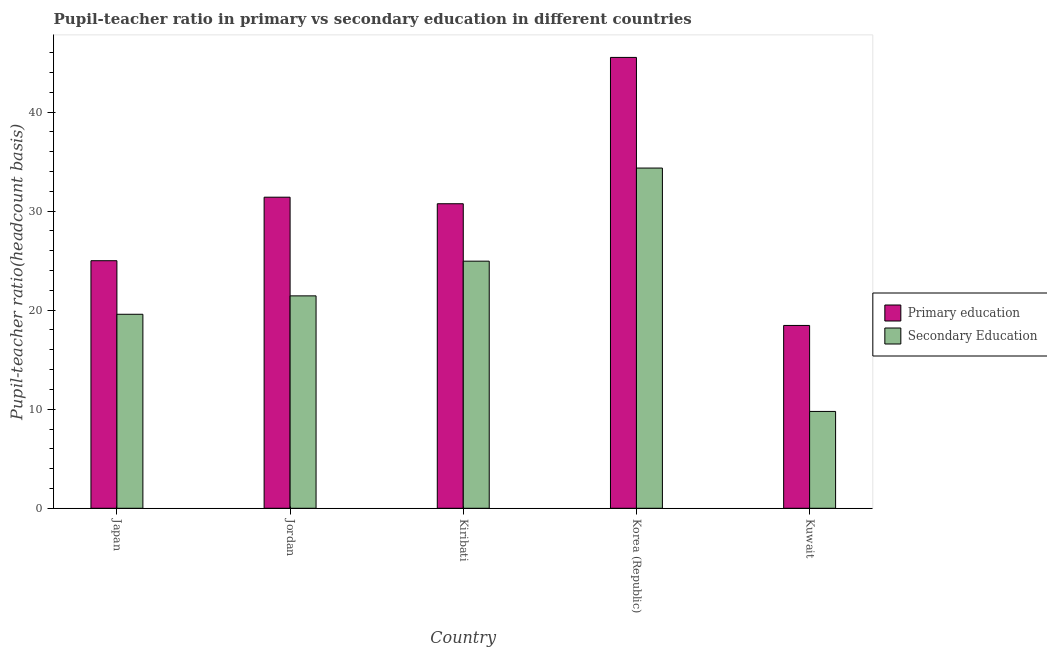How many different coloured bars are there?
Provide a succinct answer. 2. Are the number of bars per tick equal to the number of legend labels?
Your response must be concise. Yes. Are the number of bars on each tick of the X-axis equal?
Your response must be concise. Yes. How many bars are there on the 2nd tick from the right?
Offer a terse response. 2. What is the label of the 3rd group of bars from the left?
Your answer should be very brief. Kiribati. What is the pupil-teacher ratio in primary education in Korea (Republic)?
Give a very brief answer. 45.52. Across all countries, what is the maximum pupil-teacher ratio in primary education?
Offer a very short reply. 45.52. Across all countries, what is the minimum pupil-teacher ratio in primary education?
Your answer should be very brief. 18.46. In which country was the pupil teacher ratio on secondary education minimum?
Your answer should be very brief. Kuwait. What is the total pupil teacher ratio on secondary education in the graph?
Provide a short and direct response. 110.11. What is the difference between the pupil-teacher ratio in primary education in Japan and that in Kiribati?
Make the answer very short. -5.75. What is the difference between the pupil-teacher ratio in primary education in Korea (Republic) and the pupil teacher ratio on secondary education in Kuwait?
Offer a terse response. 35.74. What is the average pupil teacher ratio on secondary education per country?
Your answer should be very brief. 22.02. What is the difference between the pupil-teacher ratio in primary education and pupil teacher ratio on secondary education in Kuwait?
Offer a terse response. 8.68. In how many countries, is the pupil-teacher ratio in primary education greater than 28 ?
Your answer should be compact. 3. What is the ratio of the pupil-teacher ratio in primary education in Jordan to that in Kiribati?
Provide a short and direct response. 1.02. What is the difference between the highest and the second highest pupil teacher ratio on secondary education?
Your response must be concise. 9.4. What is the difference between the highest and the lowest pupil teacher ratio on secondary education?
Ensure brevity in your answer.  24.57. In how many countries, is the pupil teacher ratio on secondary education greater than the average pupil teacher ratio on secondary education taken over all countries?
Keep it short and to the point. 2. What does the 2nd bar from the left in Kiribati represents?
Your answer should be very brief. Secondary Education. What does the 2nd bar from the right in Kuwait represents?
Your answer should be very brief. Primary education. How many countries are there in the graph?
Your answer should be very brief. 5. What is the difference between two consecutive major ticks on the Y-axis?
Offer a terse response. 10. Where does the legend appear in the graph?
Make the answer very short. Center right. What is the title of the graph?
Keep it short and to the point. Pupil-teacher ratio in primary vs secondary education in different countries. Does "Male labourers" appear as one of the legend labels in the graph?
Offer a very short reply. No. What is the label or title of the X-axis?
Your response must be concise. Country. What is the label or title of the Y-axis?
Offer a very short reply. Pupil-teacher ratio(headcount basis). What is the Pupil-teacher ratio(headcount basis) of Primary education in Japan?
Keep it short and to the point. 24.99. What is the Pupil-teacher ratio(headcount basis) of Secondary Education in Japan?
Your response must be concise. 19.59. What is the Pupil-teacher ratio(headcount basis) of Primary education in Jordan?
Provide a succinct answer. 31.41. What is the Pupil-teacher ratio(headcount basis) in Secondary Education in Jordan?
Your response must be concise. 21.45. What is the Pupil-teacher ratio(headcount basis) of Primary education in Kiribati?
Keep it short and to the point. 30.75. What is the Pupil-teacher ratio(headcount basis) in Secondary Education in Kiribati?
Ensure brevity in your answer.  24.95. What is the Pupil-teacher ratio(headcount basis) in Primary education in Korea (Republic)?
Offer a very short reply. 45.52. What is the Pupil-teacher ratio(headcount basis) in Secondary Education in Korea (Republic)?
Offer a terse response. 34.35. What is the Pupil-teacher ratio(headcount basis) of Primary education in Kuwait?
Your answer should be compact. 18.46. What is the Pupil-teacher ratio(headcount basis) in Secondary Education in Kuwait?
Make the answer very short. 9.78. Across all countries, what is the maximum Pupil-teacher ratio(headcount basis) of Primary education?
Offer a very short reply. 45.52. Across all countries, what is the maximum Pupil-teacher ratio(headcount basis) in Secondary Education?
Your answer should be very brief. 34.35. Across all countries, what is the minimum Pupil-teacher ratio(headcount basis) of Primary education?
Offer a very short reply. 18.46. Across all countries, what is the minimum Pupil-teacher ratio(headcount basis) in Secondary Education?
Give a very brief answer. 9.78. What is the total Pupil-teacher ratio(headcount basis) in Primary education in the graph?
Ensure brevity in your answer.  151.13. What is the total Pupil-teacher ratio(headcount basis) in Secondary Education in the graph?
Offer a very short reply. 110.11. What is the difference between the Pupil-teacher ratio(headcount basis) of Primary education in Japan and that in Jordan?
Offer a very short reply. -6.41. What is the difference between the Pupil-teacher ratio(headcount basis) in Secondary Education in Japan and that in Jordan?
Offer a very short reply. -1.86. What is the difference between the Pupil-teacher ratio(headcount basis) in Primary education in Japan and that in Kiribati?
Provide a succinct answer. -5.75. What is the difference between the Pupil-teacher ratio(headcount basis) of Secondary Education in Japan and that in Kiribati?
Provide a short and direct response. -5.36. What is the difference between the Pupil-teacher ratio(headcount basis) in Primary education in Japan and that in Korea (Republic)?
Offer a very short reply. -20.53. What is the difference between the Pupil-teacher ratio(headcount basis) of Secondary Education in Japan and that in Korea (Republic)?
Make the answer very short. -14.76. What is the difference between the Pupil-teacher ratio(headcount basis) of Primary education in Japan and that in Kuwait?
Keep it short and to the point. 6.54. What is the difference between the Pupil-teacher ratio(headcount basis) of Secondary Education in Japan and that in Kuwait?
Your response must be concise. 9.81. What is the difference between the Pupil-teacher ratio(headcount basis) of Primary education in Jordan and that in Kiribati?
Make the answer very short. 0.66. What is the difference between the Pupil-teacher ratio(headcount basis) in Secondary Education in Jordan and that in Kiribati?
Make the answer very short. -3.5. What is the difference between the Pupil-teacher ratio(headcount basis) of Primary education in Jordan and that in Korea (Republic)?
Offer a terse response. -14.11. What is the difference between the Pupil-teacher ratio(headcount basis) of Secondary Education in Jordan and that in Korea (Republic)?
Offer a terse response. -12.9. What is the difference between the Pupil-teacher ratio(headcount basis) of Primary education in Jordan and that in Kuwait?
Keep it short and to the point. 12.95. What is the difference between the Pupil-teacher ratio(headcount basis) of Secondary Education in Jordan and that in Kuwait?
Keep it short and to the point. 11.67. What is the difference between the Pupil-teacher ratio(headcount basis) of Primary education in Kiribati and that in Korea (Republic)?
Ensure brevity in your answer.  -14.77. What is the difference between the Pupil-teacher ratio(headcount basis) in Secondary Education in Kiribati and that in Korea (Republic)?
Provide a short and direct response. -9.4. What is the difference between the Pupil-teacher ratio(headcount basis) of Primary education in Kiribati and that in Kuwait?
Make the answer very short. 12.29. What is the difference between the Pupil-teacher ratio(headcount basis) in Secondary Education in Kiribati and that in Kuwait?
Your answer should be very brief. 15.17. What is the difference between the Pupil-teacher ratio(headcount basis) of Primary education in Korea (Republic) and that in Kuwait?
Keep it short and to the point. 27.06. What is the difference between the Pupil-teacher ratio(headcount basis) in Secondary Education in Korea (Republic) and that in Kuwait?
Your answer should be compact. 24.57. What is the difference between the Pupil-teacher ratio(headcount basis) in Primary education in Japan and the Pupil-teacher ratio(headcount basis) in Secondary Education in Jordan?
Offer a very short reply. 3.55. What is the difference between the Pupil-teacher ratio(headcount basis) in Primary education in Japan and the Pupil-teacher ratio(headcount basis) in Secondary Education in Kiribati?
Provide a short and direct response. 0.05. What is the difference between the Pupil-teacher ratio(headcount basis) in Primary education in Japan and the Pupil-teacher ratio(headcount basis) in Secondary Education in Korea (Republic)?
Provide a succinct answer. -9.36. What is the difference between the Pupil-teacher ratio(headcount basis) of Primary education in Japan and the Pupil-teacher ratio(headcount basis) of Secondary Education in Kuwait?
Your response must be concise. 15.22. What is the difference between the Pupil-teacher ratio(headcount basis) in Primary education in Jordan and the Pupil-teacher ratio(headcount basis) in Secondary Education in Kiribati?
Provide a succinct answer. 6.46. What is the difference between the Pupil-teacher ratio(headcount basis) in Primary education in Jordan and the Pupil-teacher ratio(headcount basis) in Secondary Education in Korea (Republic)?
Offer a very short reply. -2.94. What is the difference between the Pupil-teacher ratio(headcount basis) of Primary education in Jordan and the Pupil-teacher ratio(headcount basis) of Secondary Education in Kuwait?
Keep it short and to the point. 21.63. What is the difference between the Pupil-teacher ratio(headcount basis) of Primary education in Kiribati and the Pupil-teacher ratio(headcount basis) of Secondary Education in Korea (Republic)?
Offer a very short reply. -3.6. What is the difference between the Pupil-teacher ratio(headcount basis) of Primary education in Kiribati and the Pupil-teacher ratio(headcount basis) of Secondary Education in Kuwait?
Provide a succinct answer. 20.97. What is the difference between the Pupil-teacher ratio(headcount basis) of Primary education in Korea (Republic) and the Pupil-teacher ratio(headcount basis) of Secondary Education in Kuwait?
Make the answer very short. 35.74. What is the average Pupil-teacher ratio(headcount basis) of Primary education per country?
Make the answer very short. 30.23. What is the average Pupil-teacher ratio(headcount basis) in Secondary Education per country?
Keep it short and to the point. 22.02. What is the difference between the Pupil-teacher ratio(headcount basis) in Primary education and Pupil-teacher ratio(headcount basis) in Secondary Education in Japan?
Provide a short and direct response. 5.41. What is the difference between the Pupil-teacher ratio(headcount basis) of Primary education and Pupil-teacher ratio(headcount basis) of Secondary Education in Jordan?
Ensure brevity in your answer.  9.96. What is the difference between the Pupil-teacher ratio(headcount basis) of Primary education and Pupil-teacher ratio(headcount basis) of Secondary Education in Kiribati?
Your response must be concise. 5.8. What is the difference between the Pupil-teacher ratio(headcount basis) in Primary education and Pupil-teacher ratio(headcount basis) in Secondary Education in Korea (Republic)?
Offer a terse response. 11.17. What is the difference between the Pupil-teacher ratio(headcount basis) of Primary education and Pupil-teacher ratio(headcount basis) of Secondary Education in Kuwait?
Offer a terse response. 8.68. What is the ratio of the Pupil-teacher ratio(headcount basis) of Primary education in Japan to that in Jordan?
Your response must be concise. 0.8. What is the ratio of the Pupil-teacher ratio(headcount basis) of Secondary Education in Japan to that in Jordan?
Give a very brief answer. 0.91. What is the ratio of the Pupil-teacher ratio(headcount basis) of Primary education in Japan to that in Kiribati?
Provide a succinct answer. 0.81. What is the ratio of the Pupil-teacher ratio(headcount basis) of Secondary Education in Japan to that in Kiribati?
Make the answer very short. 0.79. What is the ratio of the Pupil-teacher ratio(headcount basis) in Primary education in Japan to that in Korea (Republic)?
Your response must be concise. 0.55. What is the ratio of the Pupil-teacher ratio(headcount basis) of Secondary Education in Japan to that in Korea (Republic)?
Provide a succinct answer. 0.57. What is the ratio of the Pupil-teacher ratio(headcount basis) in Primary education in Japan to that in Kuwait?
Provide a succinct answer. 1.35. What is the ratio of the Pupil-teacher ratio(headcount basis) of Secondary Education in Japan to that in Kuwait?
Offer a terse response. 2. What is the ratio of the Pupil-teacher ratio(headcount basis) of Primary education in Jordan to that in Kiribati?
Your answer should be very brief. 1.02. What is the ratio of the Pupil-teacher ratio(headcount basis) of Secondary Education in Jordan to that in Kiribati?
Keep it short and to the point. 0.86. What is the ratio of the Pupil-teacher ratio(headcount basis) in Primary education in Jordan to that in Korea (Republic)?
Give a very brief answer. 0.69. What is the ratio of the Pupil-teacher ratio(headcount basis) in Secondary Education in Jordan to that in Korea (Republic)?
Keep it short and to the point. 0.62. What is the ratio of the Pupil-teacher ratio(headcount basis) in Primary education in Jordan to that in Kuwait?
Keep it short and to the point. 1.7. What is the ratio of the Pupil-teacher ratio(headcount basis) in Secondary Education in Jordan to that in Kuwait?
Your answer should be compact. 2.19. What is the ratio of the Pupil-teacher ratio(headcount basis) in Primary education in Kiribati to that in Korea (Republic)?
Offer a very short reply. 0.68. What is the ratio of the Pupil-teacher ratio(headcount basis) in Secondary Education in Kiribati to that in Korea (Republic)?
Your answer should be compact. 0.73. What is the ratio of the Pupil-teacher ratio(headcount basis) of Primary education in Kiribati to that in Kuwait?
Ensure brevity in your answer.  1.67. What is the ratio of the Pupil-teacher ratio(headcount basis) of Secondary Education in Kiribati to that in Kuwait?
Offer a terse response. 2.55. What is the ratio of the Pupil-teacher ratio(headcount basis) in Primary education in Korea (Republic) to that in Kuwait?
Provide a succinct answer. 2.47. What is the ratio of the Pupil-teacher ratio(headcount basis) in Secondary Education in Korea (Republic) to that in Kuwait?
Offer a very short reply. 3.51. What is the difference between the highest and the second highest Pupil-teacher ratio(headcount basis) in Primary education?
Give a very brief answer. 14.11. What is the difference between the highest and the second highest Pupil-teacher ratio(headcount basis) in Secondary Education?
Your response must be concise. 9.4. What is the difference between the highest and the lowest Pupil-teacher ratio(headcount basis) in Primary education?
Give a very brief answer. 27.06. What is the difference between the highest and the lowest Pupil-teacher ratio(headcount basis) of Secondary Education?
Give a very brief answer. 24.57. 